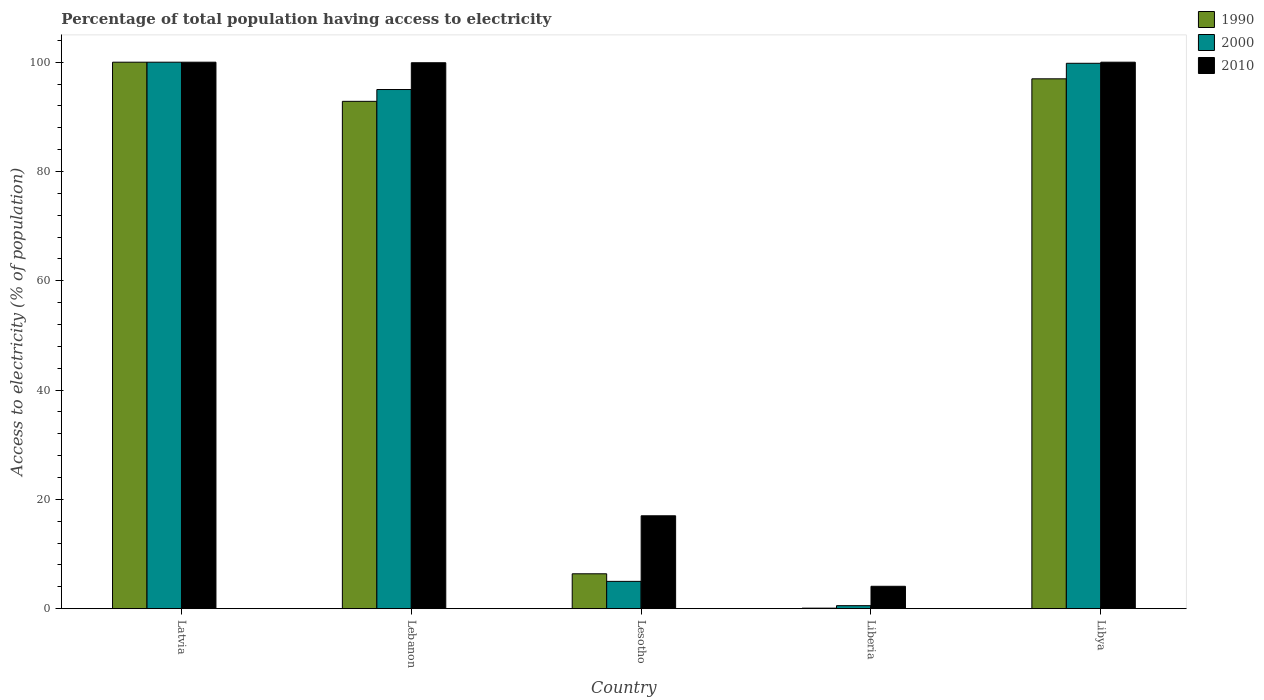How many groups of bars are there?
Ensure brevity in your answer.  5. Are the number of bars on each tick of the X-axis equal?
Your answer should be very brief. Yes. How many bars are there on the 5th tick from the left?
Your answer should be very brief. 3. What is the label of the 4th group of bars from the left?
Offer a terse response. Liberia. In how many cases, is the number of bars for a given country not equal to the number of legend labels?
Your answer should be compact. 0. What is the percentage of population that have access to electricity in 1990 in Lebanon?
Offer a very short reply. 92.84. In which country was the percentage of population that have access to electricity in 2010 maximum?
Offer a terse response. Latvia. In which country was the percentage of population that have access to electricity in 2000 minimum?
Provide a short and direct response. Liberia. What is the total percentage of population that have access to electricity in 1990 in the graph?
Keep it short and to the point. 296.29. What is the difference between the percentage of population that have access to electricity in 2000 in Latvia and that in Liberia?
Offer a very short reply. 99.44. What is the difference between the percentage of population that have access to electricity in 2010 in Lebanon and the percentage of population that have access to electricity in 1990 in Liberia?
Give a very brief answer. 99.8. What is the average percentage of population that have access to electricity in 2010 per country?
Provide a short and direct response. 64.2. What is the difference between the percentage of population that have access to electricity of/in 2010 and percentage of population that have access to electricity of/in 1990 in Latvia?
Your answer should be compact. 0. In how many countries, is the percentage of population that have access to electricity in 1990 greater than 52 %?
Provide a short and direct response. 3. What is the ratio of the percentage of population that have access to electricity in 1990 in Lebanon to that in Lesotho?
Provide a short and direct response. 14.53. What is the difference between the highest and the second highest percentage of population that have access to electricity in 2000?
Your answer should be compact. -0.2. What is the difference between the highest and the lowest percentage of population that have access to electricity in 1990?
Provide a short and direct response. 99.9. In how many countries, is the percentage of population that have access to electricity in 2010 greater than the average percentage of population that have access to electricity in 2010 taken over all countries?
Your answer should be compact. 3. Is the sum of the percentage of population that have access to electricity in 2000 in Liberia and Libya greater than the maximum percentage of population that have access to electricity in 2010 across all countries?
Offer a terse response. Yes. How many bars are there?
Ensure brevity in your answer.  15. Are all the bars in the graph horizontal?
Offer a very short reply. No. Does the graph contain grids?
Keep it short and to the point. No. How many legend labels are there?
Your answer should be compact. 3. How are the legend labels stacked?
Offer a very short reply. Vertical. What is the title of the graph?
Give a very brief answer. Percentage of total population having access to electricity. What is the label or title of the X-axis?
Make the answer very short. Country. What is the label or title of the Y-axis?
Your answer should be compact. Access to electricity (% of population). What is the Access to electricity (% of population) in 1990 in Latvia?
Ensure brevity in your answer.  100. What is the Access to electricity (% of population) in 2000 in Latvia?
Offer a terse response. 100. What is the Access to electricity (% of population) of 1990 in Lebanon?
Make the answer very short. 92.84. What is the Access to electricity (% of population) in 2000 in Lebanon?
Offer a very short reply. 95. What is the Access to electricity (% of population) in 2010 in Lebanon?
Provide a short and direct response. 99.9. What is the Access to electricity (% of population) in 1990 in Lesotho?
Provide a succinct answer. 6.39. What is the Access to electricity (% of population) of 2010 in Lesotho?
Your answer should be compact. 17. What is the Access to electricity (% of population) in 2000 in Liberia?
Provide a short and direct response. 0.56. What is the Access to electricity (% of population) of 1990 in Libya?
Your answer should be compact. 96.96. What is the Access to electricity (% of population) of 2000 in Libya?
Offer a very short reply. 99.8. Across all countries, what is the maximum Access to electricity (% of population) of 1990?
Provide a short and direct response. 100. Across all countries, what is the minimum Access to electricity (% of population) of 1990?
Offer a terse response. 0.1. Across all countries, what is the minimum Access to electricity (% of population) of 2000?
Provide a short and direct response. 0.56. Across all countries, what is the minimum Access to electricity (% of population) of 2010?
Provide a short and direct response. 4.1. What is the total Access to electricity (% of population) in 1990 in the graph?
Give a very brief answer. 296.29. What is the total Access to electricity (% of population) in 2000 in the graph?
Your answer should be very brief. 300.36. What is the total Access to electricity (% of population) in 2010 in the graph?
Your answer should be very brief. 321. What is the difference between the Access to electricity (% of population) in 1990 in Latvia and that in Lebanon?
Your answer should be very brief. 7.16. What is the difference between the Access to electricity (% of population) of 2010 in Latvia and that in Lebanon?
Ensure brevity in your answer.  0.1. What is the difference between the Access to electricity (% of population) in 1990 in Latvia and that in Lesotho?
Your answer should be very brief. 93.61. What is the difference between the Access to electricity (% of population) in 1990 in Latvia and that in Liberia?
Your response must be concise. 99.9. What is the difference between the Access to electricity (% of population) of 2000 in Latvia and that in Liberia?
Your response must be concise. 99.44. What is the difference between the Access to electricity (% of population) of 2010 in Latvia and that in Liberia?
Offer a terse response. 95.9. What is the difference between the Access to electricity (% of population) in 1990 in Latvia and that in Libya?
Ensure brevity in your answer.  3.04. What is the difference between the Access to electricity (% of population) in 2000 in Latvia and that in Libya?
Offer a very short reply. 0.2. What is the difference between the Access to electricity (% of population) in 2010 in Latvia and that in Libya?
Offer a terse response. 0. What is the difference between the Access to electricity (% of population) in 1990 in Lebanon and that in Lesotho?
Give a very brief answer. 86.45. What is the difference between the Access to electricity (% of population) in 2010 in Lebanon and that in Lesotho?
Your answer should be compact. 82.9. What is the difference between the Access to electricity (% of population) of 1990 in Lebanon and that in Liberia?
Give a very brief answer. 92.74. What is the difference between the Access to electricity (% of population) in 2000 in Lebanon and that in Liberia?
Offer a very short reply. 94.44. What is the difference between the Access to electricity (% of population) in 2010 in Lebanon and that in Liberia?
Your answer should be very brief. 95.8. What is the difference between the Access to electricity (% of population) in 1990 in Lebanon and that in Libya?
Provide a short and direct response. -4.12. What is the difference between the Access to electricity (% of population) of 2010 in Lebanon and that in Libya?
Your response must be concise. -0.1. What is the difference between the Access to electricity (% of population) of 1990 in Lesotho and that in Liberia?
Your response must be concise. 6.29. What is the difference between the Access to electricity (% of population) in 2000 in Lesotho and that in Liberia?
Your response must be concise. 4.44. What is the difference between the Access to electricity (% of population) of 1990 in Lesotho and that in Libya?
Your answer should be very brief. -90.57. What is the difference between the Access to electricity (% of population) of 2000 in Lesotho and that in Libya?
Offer a terse response. -94.8. What is the difference between the Access to electricity (% of population) of 2010 in Lesotho and that in Libya?
Keep it short and to the point. -83. What is the difference between the Access to electricity (% of population) in 1990 in Liberia and that in Libya?
Ensure brevity in your answer.  -96.86. What is the difference between the Access to electricity (% of population) of 2000 in Liberia and that in Libya?
Ensure brevity in your answer.  -99.24. What is the difference between the Access to electricity (% of population) in 2010 in Liberia and that in Libya?
Offer a terse response. -95.9. What is the difference between the Access to electricity (% of population) of 1990 in Latvia and the Access to electricity (% of population) of 2000 in Lebanon?
Your response must be concise. 5. What is the difference between the Access to electricity (% of population) of 1990 in Latvia and the Access to electricity (% of population) of 2010 in Lebanon?
Give a very brief answer. 0.1. What is the difference between the Access to electricity (% of population) in 2000 in Latvia and the Access to electricity (% of population) in 2010 in Lebanon?
Make the answer very short. 0.1. What is the difference between the Access to electricity (% of population) in 1990 in Latvia and the Access to electricity (% of population) in 2000 in Lesotho?
Offer a very short reply. 95. What is the difference between the Access to electricity (% of population) in 2000 in Latvia and the Access to electricity (% of population) in 2010 in Lesotho?
Give a very brief answer. 83. What is the difference between the Access to electricity (% of population) of 1990 in Latvia and the Access to electricity (% of population) of 2000 in Liberia?
Keep it short and to the point. 99.44. What is the difference between the Access to electricity (% of population) of 1990 in Latvia and the Access to electricity (% of population) of 2010 in Liberia?
Your response must be concise. 95.9. What is the difference between the Access to electricity (% of population) in 2000 in Latvia and the Access to electricity (% of population) in 2010 in Liberia?
Ensure brevity in your answer.  95.9. What is the difference between the Access to electricity (% of population) of 1990 in Latvia and the Access to electricity (% of population) of 2000 in Libya?
Make the answer very short. 0.2. What is the difference between the Access to electricity (% of population) in 2000 in Latvia and the Access to electricity (% of population) in 2010 in Libya?
Keep it short and to the point. 0. What is the difference between the Access to electricity (% of population) in 1990 in Lebanon and the Access to electricity (% of population) in 2000 in Lesotho?
Provide a succinct answer. 87.84. What is the difference between the Access to electricity (% of population) in 1990 in Lebanon and the Access to electricity (% of population) in 2010 in Lesotho?
Provide a succinct answer. 75.84. What is the difference between the Access to electricity (% of population) in 1990 in Lebanon and the Access to electricity (% of population) in 2000 in Liberia?
Keep it short and to the point. 92.28. What is the difference between the Access to electricity (% of population) in 1990 in Lebanon and the Access to electricity (% of population) in 2010 in Liberia?
Your answer should be compact. 88.74. What is the difference between the Access to electricity (% of population) in 2000 in Lebanon and the Access to electricity (% of population) in 2010 in Liberia?
Your response must be concise. 90.9. What is the difference between the Access to electricity (% of population) in 1990 in Lebanon and the Access to electricity (% of population) in 2000 in Libya?
Provide a short and direct response. -6.96. What is the difference between the Access to electricity (% of population) in 1990 in Lebanon and the Access to electricity (% of population) in 2010 in Libya?
Make the answer very short. -7.16. What is the difference between the Access to electricity (% of population) of 2000 in Lebanon and the Access to electricity (% of population) of 2010 in Libya?
Your answer should be compact. -5. What is the difference between the Access to electricity (% of population) in 1990 in Lesotho and the Access to electricity (% of population) in 2000 in Liberia?
Give a very brief answer. 5.83. What is the difference between the Access to electricity (% of population) of 1990 in Lesotho and the Access to electricity (% of population) of 2010 in Liberia?
Keep it short and to the point. 2.29. What is the difference between the Access to electricity (% of population) in 2000 in Lesotho and the Access to electricity (% of population) in 2010 in Liberia?
Keep it short and to the point. 0.9. What is the difference between the Access to electricity (% of population) of 1990 in Lesotho and the Access to electricity (% of population) of 2000 in Libya?
Provide a short and direct response. -93.41. What is the difference between the Access to electricity (% of population) in 1990 in Lesotho and the Access to electricity (% of population) in 2010 in Libya?
Make the answer very short. -93.61. What is the difference between the Access to electricity (% of population) of 2000 in Lesotho and the Access to electricity (% of population) of 2010 in Libya?
Offer a very short reply. -95. What is the difference between the Access to electricity (% of population) of 1990 in Liberia and the Access to electricity (% of population) of 2000 in Libya?
Your answer should be compact. -99.7. What is the difference between the Access to electricity (% of population) in 1990 in Liberia and the Access to electricity (% of population) in 2010 in Libya?
Make the answer very short. -99.9. What is the difference between the Access to electricity (% of population) in 2000 in Liberia and the Access to electricity (% of population) in 2010 in Libya?
Ensure brevity in your answer.  -99.44. What is the average Access to electricity (% of population) in 1990 per country?
Give a very brief answer. 59.26. What is the average Access to electricity (% of population) of 2000 per country?
Keep it short and to the point. 60.07. What is the average Access to electricity (% of population) in 2010 per country?
Your answer should be compact. 64.2. What is the difference between the Access to electricity (% of population) in 1990 and Access to electricity (% of population) in 2010 in Latvia?
Offer a very short reply. 0. What is the difference between the Access to electricity (% of population) of 2000 and Access to electricity (% of population) of 2010 in Latvia?
Offer a very short reply. 0. What is the difference between the Access to electricity (% of population) in 1990 and Access to electricity (% of population) in 2000 in Lebanon?
Your answer should be compact. -2.16. What is the difference between the Access to electricity (% of population) in 1990 and Access to electricity (% of population) in 2010 in Lebanon?
Provide a succinct answer. -7.06. What is the difference between the Access to electricity (% of population) in 1990 and Access to electricity (% of population) in 2000 in Lesotho?
Provide a short and direct response. 1.39. What is the difference between the Access to electricity (% of population) in 1990 and Access to electricity (% of population) in 2010 in Lesotho?
Provide a succinct answer. -10.61. What is the difference between the Access to electricity (% of population) in 2000 and Access to electricity (% of population) in 2010 in Lesotho?
Ensure brevity in your answer.  -12. What is the difference between the Access to electricity (% of population) of 1990 and Access to electricity (% of population) of 2000 in Liberia?
Your response must be concise. -0.46. What is the difference between the Access to electricity (% of population) of 1990 and Access to electricity (% of population) of 2010 in Liberia?
Your answer should be very brief. -4. What is the difference between the Access to electricity (% of population) in 2000 and Access to electricity (% of population) in 2010 in Liberia?
Your response must be concise. -3.54. What is the difference between the Access to electricity (% of population) in 1990 and Access to electricity (% of population) in 2000 in Libya?
Your answer should be compact. -2.84. What is the difference between the Access to electricity (% of population) in 1990 and Access to electricity (% of population) in 2010 in Libya?
Ensure brevity in your answer.  -3.04. What is the difference between the Access to electricity (% of population) in 2000 and Access to electricity (% of population) in 2010 in Libya?
Provide a succinct answer. -0.2. What is the ratio of the Access to electricity (% of population) in 1990 in Latvia to that in Lebanon?
Make the answer very short. 1.08. What is the ratio of the Access to electricity (% of population) of 2000 in Latvia to that in Lebanon?
Make the answer very short. 1.05. What is the ratio of the Access to electricity (% of population) of 1990 in Latvia to that in Lesotho?
Provide a short and direct response. 15.65. What is the ratio of the Access to electricity (% of population) in 2010 in Latvia to that in Lesotho?
Offer a terse response. 5.88. What is the ratio of the Access to electricity (% of population) of 2000 in Latvia to that in Liberia?
Offer a very short reply. 179.91. What is the ratio of the Access to electricity (% of population) of 2010 in Latvia to that in Liberia?
Offer a very short reply. 24.39. What is the ratio of the Access to electricity (% of population) of 1990 in Latvia to that in Libya?
Provide a short and direct response. 1.03. What is the ratio of the Access to electricity (% of population) of 2000 in Latvia to that in Libya?
Provide a succinct answer. 1. What is the ratio of the Access to electricity (% of population) in 1990 in Lebanon to that in Lesotho?
Provide a succinct answer. 14.53. What is the ratio of the Access to electricity (% of population) of 2010 in Lebanon to that in Lesotho?
Make the answer very short. 5.88. What is the ratio of the Access to electricity (% of population) in 1990 in Lebanon to that in Liberia?
Provide a succinct answer. 928.38. What is the ratio of the Access to electricity (% of population) in 2000 in Lebanon to that in Liberia?
Make the answer very short. 170.91. What is the ratio of the Access to electricity (% of population) of 2010 in Lebanon to that in Liberia?
Your answer should be very brief. 24.37. What is the ratio of the Access to electricity (% of population) in 1990 in Lebanon to that in Libya?
Provide a short and direct response. 0.96. What is the ratio of the Access to electricity (% of population) in 2000 in Lebanon to that in Libya?
Offer a very short reply. 0.95. What is the ratio of the Access to electricity (% of population) of 2010 in Lebanon to that in Libya?
Offer a terse response. 1. What is the ratio of the Access to electricity (% of population) of 1990 in Lesotho to that in Liberia?
Offer a terse response. 63.88. What is the ratio of the Access to electricity (% of population) of 2000 in Lesotho to that in Liberia?
Provide a succinct answer. 9. What is the ratio of the Access to electricity (% of population) of 2010 in Lesotho to that in Liberia?
Your response must be concise. 4.15. What is the ratio of the Access to electricity (% of population) of 1990 in Lesotho to that in Libya?
Your answer should be very brief. 0.07. What is the ratio of the Access to electricity (% of population) of 2000 in Lesotho to that in Libya?
Offer a terse response. 0.05. What is the ratio of the Access to electricity (% of population) of 2010 in Lesotho to that in Libya?
Offer a terse response. 0.17. What is the ratio of the Access to electricity (% of population) in 2000 in Liberia to that in Libya?
Make the answer very short. 0.01. What is the ratio of the Access to electricity (% of population) of 2010 in Liberia to that in Libya?
Offer a terse response. 0.04. What is the difference between the highest and the second highest Access to electricity (% of population) in 1990?
Give a very brief answer. 3.04. What is the difference between the highest and the lowest Access to electricity (% of population) of 1990?
Give a very brief answer. 99.9. What is the difference between the highest and the lowest Access to electricity (% of population) of 2000?
Offer a terse response. 99.44. What is the difference between the highest and the lowest Access to electricity (% of population) in 2010?
Your answer should be very brief. 95.9. 